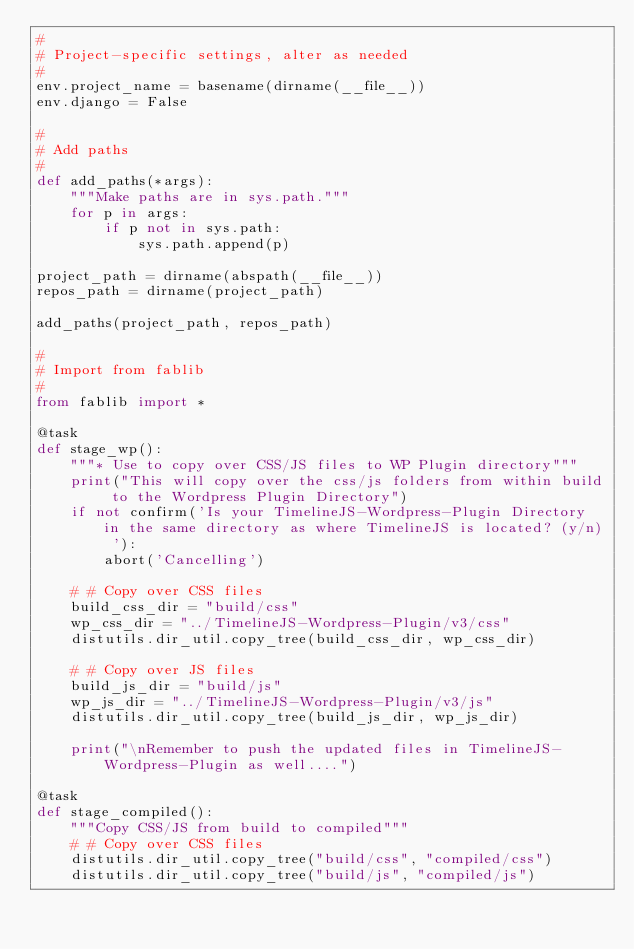Convert code to text. <code><loc_0><loc_0><loc_500><loc_500><_Python_>#
# Project-specific settings, alter as needed
#
env.project_name = basename(dirname(__file__))
env.django = False

#
# Add paths
#
def add_paths(*args):
    """Make paths are in sys.path."""
    for p in args:
        if p not in sys.path:
            sys.path.append(p)

project_path = dirname(abspath(__file__))
repos_path = dirname(project_path)

add_paths(project_path, repos_path)

#
# Import from fablib
#
from fablib import *

@task
def stage_wp():
    """* Use to copy over CSS/JS files to WP Plugin directory"""
    print("This will copy over the css/js folders from within build to the Wordpress Plugin Directory")
    if not confirm('Is your TimelineJS-Wordpress-Plugin Directory in the same directory as where TimelineJS is located? (y/n) '):
    	abort('Cancelling')

    # # Copy over CSS files
    build_css_dir = "build/css"
    wp_css_dir = "../TimelineJS-Wordpress-Plugin/v3/css"
    distutils.dir_util.copy_tree(build_css_dir, wp_css_dir)

    # # Copy over JS files
    build_js_dir = "build/js"
    wp_js_dir = "../TimelineJS-Wordpress-Plugin/v3/js"
    distutils.dir_util.copy_tree(build_js_dir, wp_js_dir)

    print("\nRemember to push the updated files in TimelineJS-Wordpress-Plugin as well....")

@task
def stage_compiled():
    """Copy CSS/JS from build to compiled"""
    # # Copy over CSS files
    distutils.dir_util.copy_tree("build/css", "compiled/css")
    distutils.dir_util.copy_tree("build/js", "compiled/js")
</code> 